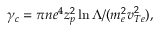<formula> <loc_0><loc_0><loc_500><loc_500>\gamma _ { c } = \pi n e ^ { 4 } z _ { p } ^ { 2 } \ln { \Lambda } / ( m _ { e } ^ { 2 } v _ { T e } ^ { 2 } ) ,</formula> 